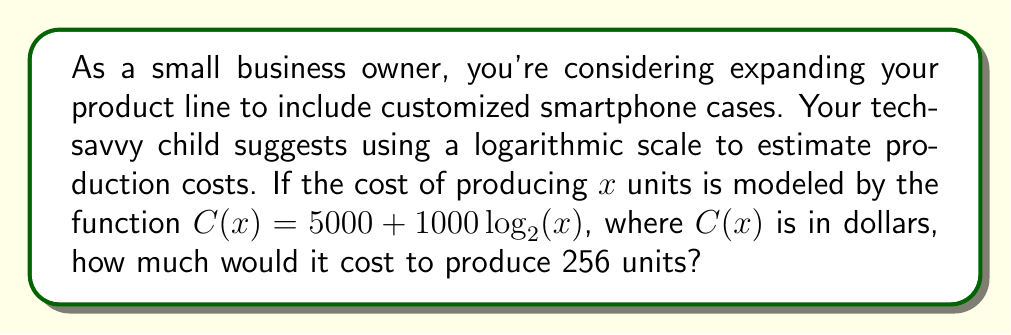Provide a solution to this math problem. Let's approach this step-by-step:

1) We're given the cost function: $C(x) = 5000 + 1000 \log_2(x)$

2) We need to find $C(256)$, so we'll substitute $x = 256$ into the function:

   $C(256) = 5000 + 1000 \log_2(256)$

3) Now, we need to calculate $\log_2(256)$. This is where our knowledge of logarithms comes in handy:

   $2^8 = 256$, so $\log_2(256) = 8$

4) Substituting this back into our equation:

   $C(256) = 5000 + 1000 \cdot 8$

5) Simplify:
   
   $C(256) = 5000 + 8000 = 13000$

Thus, it would cost $13,000 to produce 256 units.

The logarithmic scale is useful here because it models a situation where costs increase more slowly as production volume increases, reflecting economies of scale in manufacturing.
Answer: $13,000 